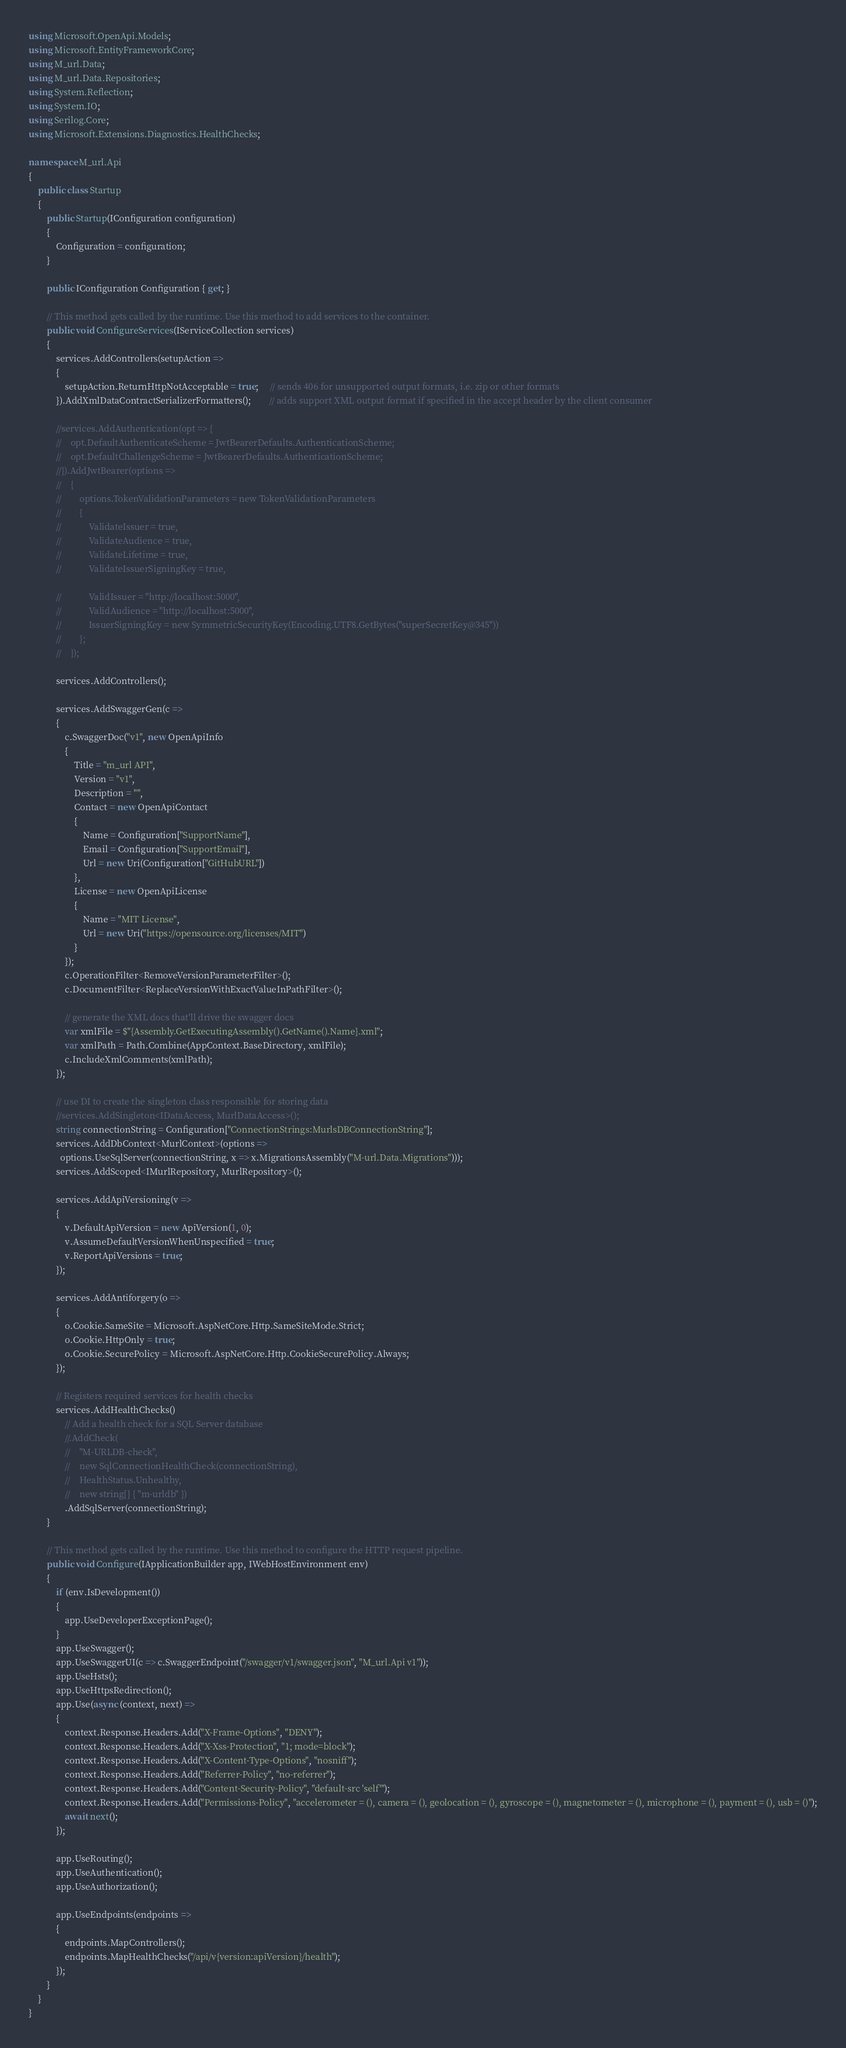Convert code to text. <code><loc_0><loc_0><loc_500><loc_500><_C#_>using Microsoft.OpenApi.Models;
using Microsoft.EntityFrameworkCore;
using M_url.Data;
using M_url.Data.Repositories;
using System.Reflection;
using System.IO;
using Serilog.Core;
using Microsoft.Extensions.Diagnostics.HealthChecks;

namespace M_url.Api
{
    public class Startup
    {
        public Startup(IConfiguration configuration)
        {
            Configuration = configuration;
        }

        public IConfiguration Configuration { get; }

        // This method gets called by the runtime. Use this method to add services to the container.
        public void ConfigureServices(IServiceCollection services)
        {
            services.AddControllers(setupAction => 
            {
                setupAction.ReturnHttpNotAcceptable = true;     // sends 406 for unsupported output formats, i.e. zip or other formats
            }).AddXmlDataContractSerializerFormatters();        // adds support XML output format if specified in the accept header by the client consumer

            //services.AddAuthentication(opt => {
            //    opt.DefaultAuthenticateScheme = JwtBearerDefaults.AuthenticationScheme;
            //    opt.DefaultChallengeScheme = JwtBearerDefaults.AuthenticationScheme;
            //}).AddJwtBearer(options =>
            //    {
            //        options.TokenValidationParameters = new TokenValidationParameters
            //        {
            //            ValidateIssuer = true,
            //            ValidateAudience = true,
            //            ValidateLifetime = true,
            //            ValidateIssuerSigningKey = true,

            //            ValidIssuer = "http://localhost:5000",
            //            ValidAudience = "http://localhost:5000",
            //            IssuerSigningKey = new SymmetricSecurityKey(Encoding.UTF8.GetBytes("superSecretKey@345"))
            //        };
            //    });

            services.AddControllers();

            services.AddSwaggerGen(c =>
            {
                c.SwaggerDoc("v1", new OpenApiInfo
                {
                    Title = "m_url API",
                    Version = "v1",
                    Description = "",
                    Contact = new OpenApiContact
                    {
                        Name = Configuration["SupportName"],
                        Email = Configuration["SupportEmail"],
                        Url = new Uri(Configuration["GitHubURL"])
                    },
                    License = new OpenApiLicense
                    {
                        Name = "MIT License",
                        Url = new Uri("https://opensource.org/licenses/MIT")
                    }
                });
                c.OperationFilter<RemoveVersionParameterFilter>();
                c.DocumentFilter<ReplaceVersionWithExactValueInPathFilter>();

                // generate the XML docs that'll drive the swagger docs
                var xmlFile = $"{Assembly.GetExecutingAssembly().GetName().Name}.xml";
                var xmlPath = Path.Combine(AppContext.BaseDirectory, xmlFile);
                c.IncludeXmlComments(xmlPath);
            });

            // use DI to create the singleton class responsible for storing data
            //services.AddSingleton<IDataAccess, MurlDataAccess>();
            string connectionString = Configuration["ConnectionStrings:MurlsDBConnectionString"];
            services.AddDbContext<MurlContext>(options =>
              options.UseSqlServer(connectionString, x => x.MigrationsAssembly("M-url.Data.Migrations")));
            services.AddScoped<IMurlRepository, MurlRepository>();

            services.AddApiVersioning(v => 
            {
                v.DefaultApiVersion = new ApiVersion(1, 0);
                v.AssumeDefaultVersionWhenUnspecified = true;
                v.ReportApiVersions = true;
            });

            services.AddAntiforgery(o => 
            { 
                o.Cookie.SameSite = Microsoft.AspNetCore.Http.SameSiteMode.Strict; 
                o.Cookie.HttpOnly = true; 
                o.Cookie.SecurePolicy = Microsoft.AspNetCore.Http.CookieSecurePolicy.Always;
            });

            // Registers required services for health checks
            services.AddHealthChecks()
                // Add a health check for a SQL Server database
                //.AddCheck(
                //    "M-URLDB-check",
                //    new SqlConnectionHealthCheck(connectionString),
                //    HealthStatus.Unhealthy,
                //    new string[] { "m-urldb" })
                .AddSqlServer(connectionString);
        }

        // This method gets called by the runtime. Use this method to configure the HTTP request pipeline.
        public void Configure(IApplicationBuilder app, IWebHostEnvironment env)
        {
            if (env.IsDevelopment())
            {
                app.UseDeveloperExceptionPage();
            }
            app.UseSwagger();
            app.UseSwaggerUI(c => c.SwaggerEndpoint("/swagger/v1/swagger.json", "M_url.Api v1"));
            app.UseHsts();
            app.UseHttpsRedirection();
            app.Use(async (context, next) =>
            {
                context.Response.Headers.Add("X-Frame-Options", "DENY");
                context.Response.Headers.Add("X-Xss-Protection", "1; mode=block");
                context.Response.Headers.Add("X-Content-Type-Options", "nosniff");
                context.Response.Headers.Add("Referrer-Policy", "no-referrer");
                context.Response.Headers.Add("Content-Security-Policy", "default-src 'self'");
                context.Response.Headers.Add("Permissions-Policy", "accelerometer = (), camera = (), geolocation = (), gyroscope = (), magnetometer = (), microphone = (), payment = (), usb = ()");
                await next();
            });

            app.UseRouting();
            app.UseAuthentication();
            app.UseAuthorization();

            app.UseEndpoints(endpoints =>
            {
                endpoints.MapControllers();
                endpoints.MapHealthChecks("/api/v{version:apiVersion}/health");
            });
        }
    }
}
</code> 